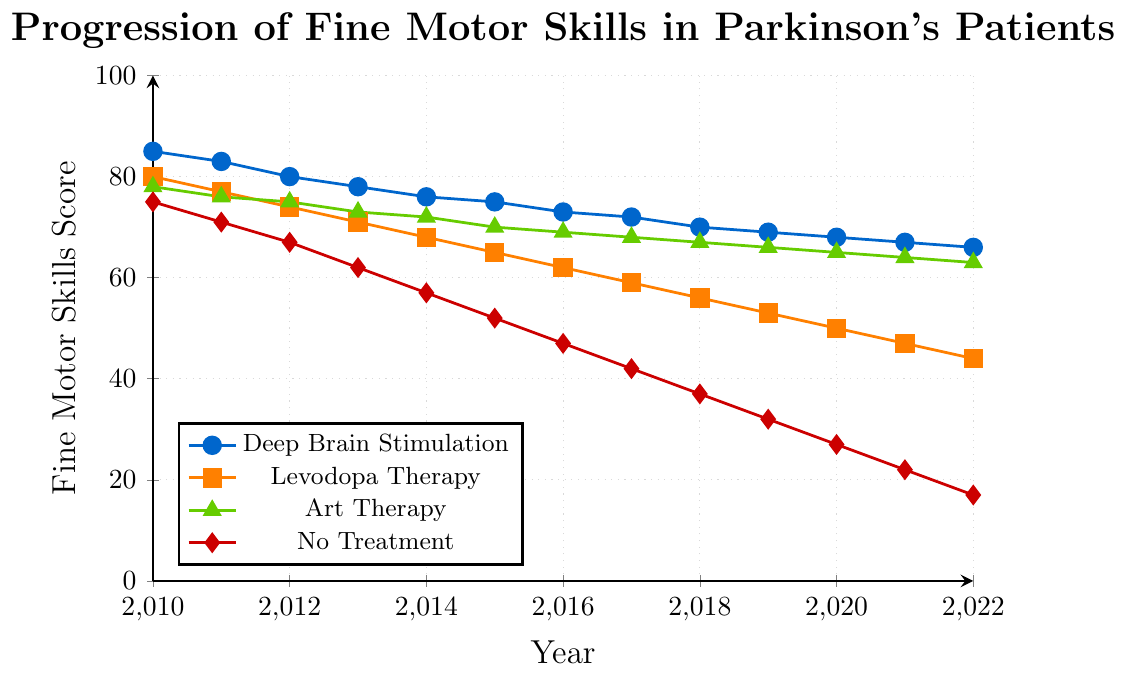Which treatment approach shows the least decline in fine motor skills over the years? By visually inspecting the lines, the "Art Therapy" line shows the smallest decline compared to the other lines. It declines more gradually, indicating it maintains fine motor skills better than other treatments.
Answer: Art Therapy How does the fine motor skills score for "No Treatment" in 2022 compare to its score in 2010? In 2010, the score for "No Treatment" is 75, and it decreases to 17 by 2022. The difference is 75 - 17, which is a significant decline.
Answer: 58 points lower What is the average fine motor skills score for "Deep Brain Stimulation" over the entire period? To find the average, sum all the scores from 2010 to 2022 and divide by the number of years. (85 + 83 + 80 + 78 + 76 + 75 + 73 + 72 + 70 + 69 + 68 + 67 + 66) / 13 = 72
Answer: 72 Comparing the trends, which treatment shows a more rapid decline in fine motor skills after 2015: "Levodopa Therapy" or "No Treatment"? Post-2015, the decline rate for "No Treatment" (drop from 52 to 17, over 5 years) is sharper than for "Levodopa Therapy" (drop from 65 to 44).
Answer: No Treatment What is the difference in fine motor skills scores between "Art Therapy" and "Levodopa Therapy" in 2020? The score for "Art Therapy" in 2020 is 65, while for "Levodopa Therapy" it is 50. The difference is 65 - 50.
Answer: 15 points Which year marks the first point at which "Art Therapy" surpassed "Levodopa Therapy" in maintaining fine motor skills? By tracing the two lines, "Art Therapy" consistently stays above "Levodopa Therapy" from 2010 onwards, indicating it was always better.
Answer: 2010 What is the proportional relationship of the fine motor skills score between "Deep Brain Stimulation" and "No Treatment" for the year 2022? The score for "Deep Brain Stimulation" is 66, and for "No Treatment", it is 17. The proportion is 66 / 17.
Answer: Approximately 3.88 How does the rate of decline of fine motor skills for "Deep Brain Stimulation" compare to "Art Therapy"? Both have a declining trend, but "Art Therapy" shows a slightly less steep decline compared to "Deep Brain Stimulation", indicating a better preservation of skills over time.
Answer: Art Therapy has a less steep decline What is the combined score of all treatment approaches in 2016? Add each treatment's score for 2016: "Deep Brain Stimulation" (73), "Levodopa Therapy" (62), "Art Therapy" (69), "No Treatment" (47). Sum = 73 + 62 + 69 + 47.
Answer: 251 